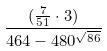Convert formula to latex. <formula><loc_0><loc_0><loc_500><loc_500>\frac { ( \frac { 7 } { 5 1 } \cdot 3 ) } { 4 6 4 - 4 8 0 ^ { \sqrt { 8 6 } } }</formula> 